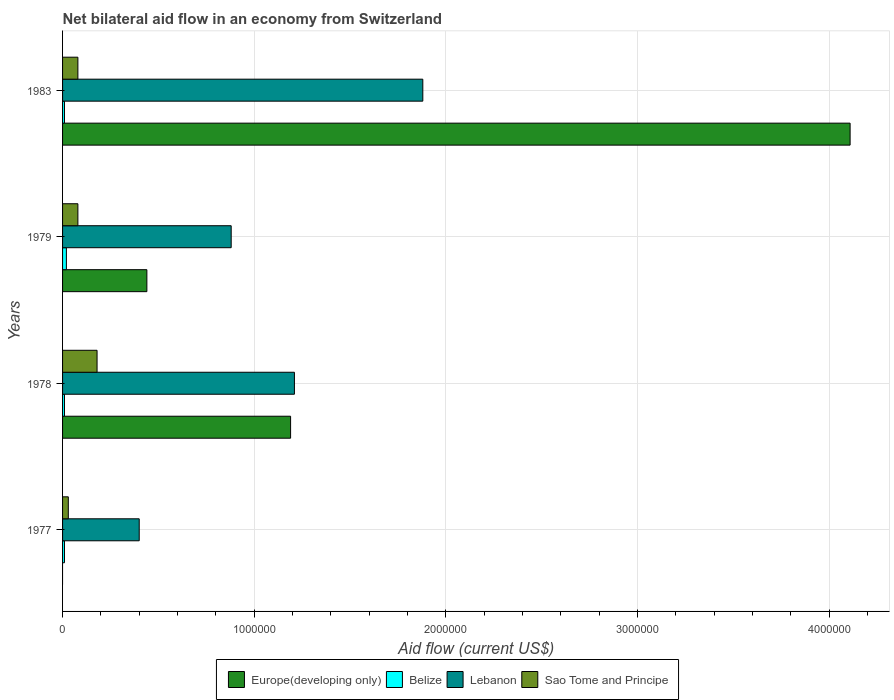How many different coloured bars are there?
Keep it short and to the point. 4. Are the number of bars per tick equal to the number of legend labels?
Provide a short and direct response. No. How many bars are there on the 1st tick from the bottom?
Make the answer very short. 3. What is the label of the 3rd group of bars from the top?
Ensure brevity in your answer.  1978. What is the net bilateral aid flow in Europe(developing only) in 1978?
Give a very brief answer. 1.19e+06. Across all years, what is the maximum net bilateral aid flow in Sao Tome and Principe?
Offer a terse response. 1.80e+05. What is the total net bilateral aid flow in Europe(developing only) in the graph?
Give a very brief answer. 5.74e+06. What is the difference between the net bilateral aid flow in Lebanon in 1979 and that in 1983?
Keep it short and to the point. -1.00e+06. What is the difference between the net bilateral aid flow in Europe(developing only) in 1979 and the net bilateral aid flow in Belize in 1978?
Your answer should be compact. 4.30e+05. What is the average net bilateral aid flow in Sao Tome and Principe per year?
Offer a very short reply. 9.25e+04. In the year 1978, what is the difference between the net bilateral aid flow in Lebanon and net bilateral aid flow in Sao Tome and Principe?
Keep it short and to the point. 1.03e+06. In how many years, is the net bilateral aid flow in Lebanon greater than 3200000 US$?
Keep it short and to the point. 0. What is the ratio of the net bilateral aid flow in Sao Tome and Principe in 1977 to that in 1978?
Offer a very short reply. 0.17. Is the net bilateral aid flow in Belize in 1977 less than that in 1979?
Your response must be concise. Yes. Is the difference between the net bilateral aid flow in Lebanon in 1977 and 1979 greater than the difference between the net bilateral aid flow in Sao Tome and Principe in 1977 and 1979?
Provide a succinct answer. No. What is the difference between the highest and the second highest net bilateral aid flow in Belize?
Offer a very short reply. 10000. What is the difference between the highest and the lowest net bilateral aid flow in Europe(developing only)?
Your answer should be compact. 4.11e+06. In how many years, is the net bilateral aid flow in Europe(developing only) greater than the average net bilateral aid flow in Europe(developing only) taken over all years?
Provide a succinct answer. 1. Is the sum of the net bilateral aid flow in Belize in 1977 and 1979 greater than the maximum net bilateral aid flow in Europe(developing only) across all years?
Make the answer very short. No. Is it the case that in every year, the sum of the net bilateral aid flow in Sao Tome and Principe and net bilateral aid flow in Lebanon is greater than the net bilateral aid flow in Belize?
Make the answer very short. Yes. How many bars are there?
Offer a very short reply. 15. How many years are there in the graph?
Your response must be concise. 4. Does the graph contain any zero values?
Provide a succinct answer. Yes. Does the graph contain grids?
Ensure brevity in your answer.  Yes. How many legend labels are there?
Ensure brevity in your answer.  4. What is the title of the graph?
Make the answer very short. Net bilateral aid flow in an economy from Switzerland. What is the Aid flow (current US$) in Europe(developing only) in 1977?
Your response must be concise. 0. What is the Aid flow (current US$) of Sao Tome and Principe in 1977?
Your answer should be very brief. 3.00e+04. What is the Aid flow (current US$) in Europe(developing only) in 1978?
Provide a short and direct response. 1.19e+06. What is the Aid flow (current US$) of Belize in 1978?
Keep it short and to the point. 10000. What is the Aid flow (current US$) of Lebanon in 1978?
Give a very brief answer. 1.21e+06. What is the Aid flow (current US$) of Europe(developing only) in 1979?
Provide a succinct answer. 4.40e+05. What is the Aid flow (current US$) of Belize in 1979?
Provide a succinct answer. 2.00e+04. What is the Aid flow (current US$) in Lebanon in 1979?
Offer a terse response. 8.80e+05. What is the Aid flow (current US$) of Sao Tome and Principe in 1979?
Provide a succinct answer. 8.00e+04. What is the Aid flow (current US$) of Europe(developing only) in 1983?
Make the answer very short. 4.11e+06. What is the Aid flow (current US$) in Belize in 1983?
Provide a short and direct response. 10000. What is the Aid flow (current US$) of Lebanon in 1983?
Make the answer very short. 1.88e+06. What is the Aid flow (current US$) in Sao Tome and Principe in 1983?
Offer a very short reply. 8.00e+04. Across all years, what is the maximum Aid flow (current US$) of Europe(developing only)?
Offer a very short reply. 4.11e+06. Across all years, what is the maximum Aid flow (current US$) of Lebanon?
Offer a terse response. 1.88e+06. Across all years, what is the minimum Aid flow (current US$) of Belize?
Keep it short and to the point. 10000. Across all years, what is the minimum Aid flow (current US$) in Lebanon?
Offer a very short reply. 4.00e+05. Across all years, what is the minimum Aid flow (current US$) of Sao Tome and Principe?
Ensure brevity in your answer.  3.00e+04. What is the total Aid flow (current US$) of Europe(developing only) in the graph?
Give a very brief answer. 5.74e+06. What is the total Aid flow (current US$) in Lebanon in the graph?
Offer a very short reply. 4.37e+06. What is the difference between the Aid flow (current US$) of Lebanon in 1977 and that in 1978?
Ensure brevity in your answer.  -8.10e+05. What is the difference between the Aid flow (current US$) of Lebanon in 1977 and that in 1979?
Ensure brevity in your answer.  -4.80e+05. What is the difference between the Aid flow (current US$) of Sao Tome and Principe in 1977 and that in 1979?
Keep it short and to the point. -5.00e+04. What is the difference between the Aid flow (current US$) of Belize in 1977 and that in 1983?
Offer a terse response. 0. What is the difference between the Aid flow (current US$) of Lebanon in 1977 and that in 1983?
Your answer should be very brief. -1.48e+06. What is the difference between the Aid flow (current US$) of Sao Tome and Principe in 1977 and that in 1983?
Provide a succinct answer. -5.00e+04. What is the difference between the Aid flow (current US$) of Europe(developing only) in 1978 and that in 1979?
Keep it short and to the point. 7.50e+05. What is the difference between the Aid flow (current US$) of Lebanon in 1978 and that in 1979?
Provide a short and direct response. 3.30e+05. What is the difference between the Aid flow (current US$) of Europe(developing only) in 1978 and that in 1983?
Offer a terse response. -2.92e+06. What is the difference between the Aid flow (current US$) in Lebanon in 1978 and that in 1983?
Keep it short and to the point. -6.70e+05. What is the difference between the Aid flow (current US$) of Europe(developing only) in 1979 and that in 1983?
Your answer should be very brief. -3.67e+06. What is the difference between the Aid flow (current US$) in Belize in 1979 and that in 1983?
Give a very brief answer. 10000. What is the difference between the Aid flow (current US$) in Belize in 1977 and the Aid flow (current US$) in Lebanon in 1978?
Your response must be concise. -1.20e+06. What is the difference between the Aid flow (current US$) of Belize in 1977 and the Aid flow (current US$) of Sao Tome and Principe in 1978?
Offer a terse response. -1.70e+05. What is the difference between the Aid flow (current US$) of Belize in 1977 and the Aid flow (current US$) of Lebanon in 1979?
Provide a succinct answer. -8.70e+05. What is the difference between the Aid flow (current US$) in Belize in 1977 and the Aid flow (current US$) in Sao Tome and Principe in 1979?
Your answer should be compact. -7.00e+04. What is the difference between the Aid flow (current US$) of Lebanon in 1977 and the Aid flow (current US$) of Sao Tome and Principe in 1979?
Make the answer very short. 3.20e+05. What is the difference between the Aid flow (current US$) in Belize in 1977 and the Aid flow (current US$) in Lebanon in 1983?
Your response must be concise. -1.87e+06. What is the difference between the Aid flow (current US$) of Europe(developing only) in 1978 and the Aid flow (current US$) of Belize in 1979?
Offer a very short reply. 1.17e+06. What is the difference between the Aid flow (current US$) in Europe(developing only) in 1978 and the Aid flow (current US$) in Sao Tome and Principe in 1979?
Your answer should be compact. 1.11e+06. What is the difference between the Aid flow (current US$) of Belize in 1978 and the Aid flow (current US$) of Lebanon in 1979?
Your response must be concise. -8.70e+05. What is the difference between the Aid flow (current US$) of Belize in 1978 and the Aid flow (current US$) of Sao Tome and Principe in 1979?
Ensure brevity in your answer.  -7.00e+04. What is the difference between the Aid flow (current US$) in Lebanon in 1978 and the Aid flow (current US$) in Sao Tome and Principe in 1979?
Provide a short and direct response. 1.13e+06. What is the difference between the Aid flow (current US$) in Europe(developing only) in 1978 and the Aid flow (current US$) in Belize in 1983?
Your answer should be compact. 1.18e+06. What is the difference between the Aid flow (current US$) of Europe(developing only) in 1978 and the Aid flow (current US$) of Lebanon in 1983?
Ensure brevity in your answer.  -6.90e+05. What is the difference between the Aid flow (current US$) of Europe(developing only) in 1978 and the Aid flow (current US$) of Sao Tome and Principe in 1983?
Offer a terse response. 1.11e+06. What is the difference between the Aid flow (current US$) in Belize in 1978 and the Aid flow (current US$) in Lebanon in 1983?
Ensure brevity in your answer.  -1.87e+06. What is the difference between the Aid flow (current US$) in Belize in 1978 and the Aid flow (current US$) in Sao Tome and Principe in 1983?
Offer a terse response. -7.00e+04. What is the difference between the Aid flow (current US$) in Lebanon in 1978 and the Aid flow (current US$) in Sao Tome and Principe in 1983?
Offer a very short reply. 1.13e+06. What is the difference between the Aid flow (current US$) of Europe(developing only) in 1979 and the Aid flow (current US$) of Belize in 1983?
Your answer should be compact. 4.30e+05. What is the difference between the Aid flow (current US$) of Europe(developing only) in 1979 and the Aid flow (current US$) of Lebanon in 1983?
Your answer should be compact. -1.44e+06. What is the difference between the Aid flow (current US$) in Europe(developing only) in 1979 and the Aid flow (current US$) in Sao Tome and Principe in 1983?
Offer a terse response. 3.60e+05. What is the difference between the Aid flow (current US$) of Belize in 1979 and the Aid flow (current US$) of Lebanon in 1983?
Your answer should be very brief. -1.86e+06. What is the difference between the Aid flow (current US$) in Belize in 1979 and the Aid flow (current US$) in Sao Tome and Principe in 1983?
Give a very brief answer. -6.00e+04. What is the average Aid flow (current US$) of Europe(developing only) per year?
Provide a succinct answer. 1.44e+06. What is the average Aid flow (current US$) of Belize per year?
Offer a very short reply. 1.25e+04. What is the average Aid flow (current US$) of Lebanon per year?
Provide a short and direct response. 1.09e+06. What is the average Aid flow (current US$) of Sao Tome and Principe per year?
Give a very brief answer. 9.25e+04. In the year 1977, what is the difference between the Aid flow (current US$) of Belize and Aid flow (current US$) of Lebanon?
Offer a terse response. -3.90e+05. In the year 1977, what is the difference between the Aid flow (current US$) in Lebanon and Aid flow (current US$) in Sao Tome and Principe?
Your response must be concise. 3.70e+05. In the year 1978, what is the difference between the Aid flow (current US$) in Europe(developing only) and Aid flow (current US$) in Belize?
Your answer should be compact. 1.18e+06. In the year 1978, what is the difference between the Aid flow (current US$) of Europe(developing only) and Aid flow (current US$) of Sao Tome and Principe?
Offer a terse response. 1.01e+06. In the year 1978, what is the difference between the Aid flow (current US$) in Belize and Aid flow (current US$) in Lebanon?
Make the answer very short. -1.20e+06. In the year 1978, what is the difference between the Aid flow (current US$) in Belize and Aid flow (current US$) in Sao Tome and Principe?
Provide a succinct answer. -1.70e+05. In the year 1978, what is the difference between the Aid flow (current US$) in Lebanon and Aid flow (current US$) in Sao Tome and Principe?
Provide a succinct answer. 1.03e+06. In the year 1979, what is the difference between the Aid flow (current US$) of Europe(developing only) and Aid flow (current US$) of Belize?
Offer a terse response. 4.20e+05. In the year 1979, what is the difference between the Aid flow (current US$) of Europe(developing only) and Aid flow (current US$) of Lebanon?
Your answer should be very brief. -4.40e+05. In the year 1979, what is the difference between the Aid flow (current US$) of Europe(developing only) and Aid flow (current US$) of Sao Tome and Principe?
Offer a very short reply. 3.60e+05. In the year 1979, what is the difference between the Aid flow (current US$) of Belize and Aid flow (current US$) of Lebanon?
Your response must be concise. -8.60e+05. In the year 1983, what is the difference between the Aid flow (current US$) of Europe(developing only) and Aid flow (current US$) of Belize?
Give a very brief answer. 4.10e+06. In the year 1983, what is the difference between the Aid flow (current US$) of Europe(developing only) and Aid flow (current US$) of Lebanon?
Keep it short and to the point. 2.23e+06. In the year 1983, what is the difference between the Aid flow (current US$) in Europe(developing only) and Aid flow (current US$) in Sao Tome and Principe?
Provide a short and direct response. 4.03e+06. In the year 1983, what is the difference between the Aid flow (current US$) of Belize and Aid flow (current US$) of Lebanon?
Your answer should be compact. -1.87e+06. In the year 1983, what is the difference between the Aid flow (current US$) of Belize and Aid flow (current US$) of Sao Tome and Principe?
Your answer should be very brief. -7.00e+04. In the year 1983, what is the difference between the Aid flow (current US$) of Lebanon and Aid flow (current US$) of Sao Tome and Principe?
Keep it short and to the point. 1.80e+06. What is the ratio of the Aid flow (current US$) in Lebanon in 1977 to that in 1978?
Your response must be concise. 0.33. What is the ratio of the Aid flow (current US$) of Belize in 1977 to that in 1979?
Make the answer very short. 0.5. What is the ratio of the Aid flow (current US$) in Lebanon in 1977 to that in 1979?
Make the answer very short. 0.45. What is the ratio of the Aid flow (current US$) in Sao Tome and Principe in 1977 to that in 1979?
Your response must be concise. 0.38. What is the ratio of the Aid flow (current US$) of Lebanon in 1977 to that in 1983?
Your answer should be very brief. 0.21. What is the ratio of the Aid flow (current US$) in Europe(developing only) in 1978 to that in 1979?
Your response must be concise. 2.7. What is the ratio of the Aid flow (current US$) in Belize in 1978 to that in 1979?
Your response must be concise. 0.5. What is the ratio of the Aid flow (current US$) in Lebanon in 1978 to that in 1979?
Make the answer very short. 1.38. What is the ratio of the Aid flow (current US$) in Sao Tome and Principe in 1978 to that in 1979?
Your response must be concise. 2.25. What is the ratio of the Aid flow (current US$) in Europe(developing only) in 1978 to that in 1983?
Offer a terse response. 0.29. What is the ratio of the Aid flow (current US$) in Belize in 1978 to that in 1983?
Your answer should be very brief. 1. What is the ratio of the Aid flow (current US$) in Lebanon in 1978 to that in 1983?
Offer a very short reply. 0.64. What is the ratio of the Aid flow (current US$) of Sao Tome and Principe in 1978 to that in 1983?
Provide a short and direct response. 2.25. What is the ratio of the Aid flow (current US$) of Europe(developing only) in 1979 to that in 1983?
Make the answer very short. 0.11. What is the ratio of the Aid flow (current US$) in Lebanon in 1979 to that in 1983?
Give a very brief answer. 0.47. What is the ratio of the Aid flow (current US$) in Sao Tome and Principe in 1979 to that in 1983?
Your answer should be compact. 1. What is the difference between the highest and the second highest Aid flow (current US$) of Europe(developing only)?
Your response must be concise. 2.92e+06. What is the difference between the highest and the second highest Aid flow (current US$) of Lebanon?
Offer a very short reply. 6.70e+05. What is the difference between the highest and the lowest Aid flow (current US$) in Europe(developing only)?
Your answer should be compact. 4.11e+06. What is the difference between the highest and the lowest Aid flow (current US$) in Lebanon?
Make the answer very short. 1.48e+06. What is the difference between the highest and the lowest Aid flow (current US$) of Sao Tome and Principe?
Provide a succinct answer. 1.50e+05. 